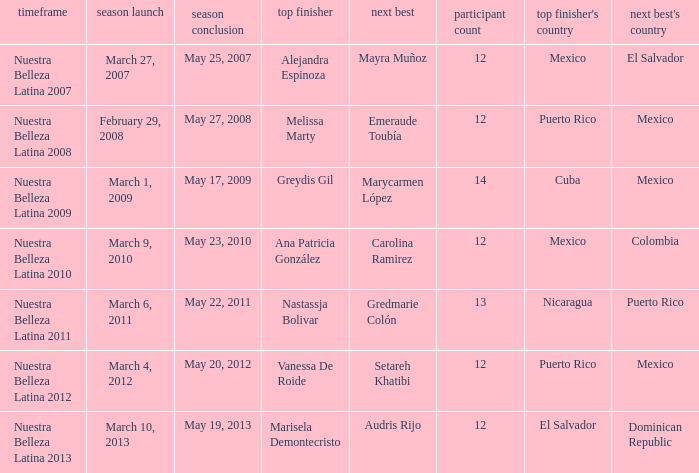How many contestants were there on March 1, 2009 during the season premiere? 14.0. 